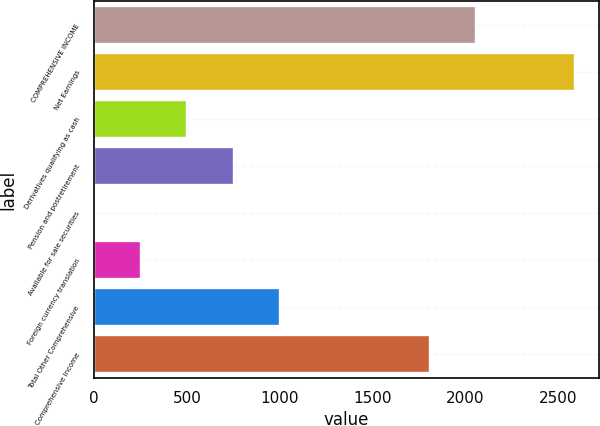Convert chart to OTSL. <chart><loc_0><loc_0><loc_500><loc_500><bar_chart><fcel>COMPREHENSIVE INCOME<fcel>Net Earnings<fcel>Derivatives qualifying as cash<fcel>Pension and postretirement<fcel>Available for sale securities<fcel>Foreign currency translation<fcel>Total Other Comprehensive<fcel>Comprehensive Income<nl><fcel>2058.8<fcel>2593.8<fcel>502.6<fcel>752.4<fcel>3<fcel>252.8<fcel>1002.2<fcel>1809<nl></chart> 